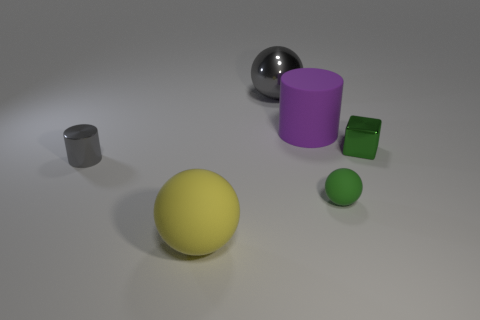How many gray metallic objects have the same shape as the big purple rubber object?
Offer a very short reply. 1. What is the color of the other metallic object that is the same size as the yellow thing?
Make the answer very short. Gray. Are there the same number of large purple rubber cylinders in front of the green matte thing and small metal things that are on the left side of the yellow object?
Make the answer very short. No. Is there a rubber ball of the same size as the purple rubber object?
Offer a terse response. Yes. What is the size of the yellow sphere?
Offer a terse response. Large. Are there an equal number of big purple rubber objects behind the purple rubber object and matte objects?
Provide a succinct answer. No. What number of other things are the same color as the big metallic object?
Your answer should be compact. 1. There is a shiny object that is both in front of the gray sphere and on the left side of the large cylinder; what is its color?
Provide a short and direct response. Gray. There is a cylinder left of the cylinder right of the sphere that is behind the purple thing; what is its size?
Ensure brevity in your answer.  Small. How many things are cubes that are in front of the big metal object or objects that are in front of the green shiny thing?
Provide a short and direct response. 4. 